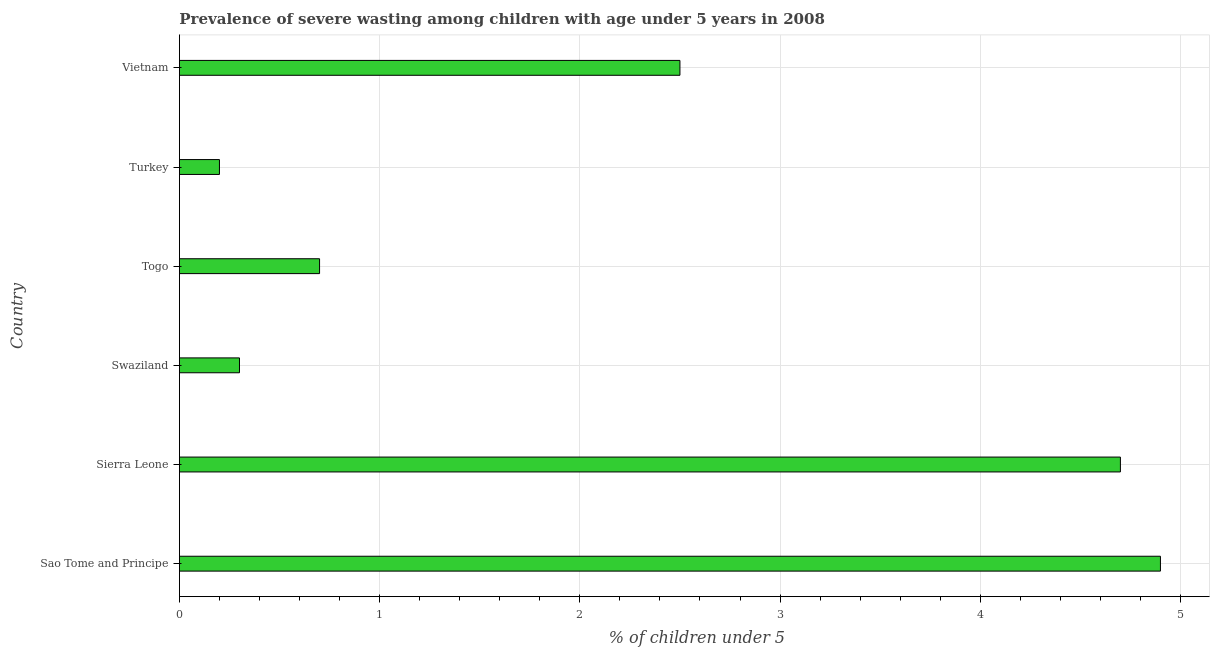Does the graph contain any zero values?
Your response must be concise. No. What is the title of the graph?
Make the answer very short. Prevalence of severe wasting among children with age under 5 years in 2008. What is the label or title of the X-axis?
Offer a very short reply.  % of children under 5. What is the label or title of the Y-axis?
Give a very brief answer. Country. What is the prevalence of severe wasting in Sierra Leone?
Offer a terse response. 4.7. Across all countries, what is the maximum prevalence of severe wasting?
Your response must be concise. 4.9. Across all countries, what is the minimum prevalence of severe wasting?
Your response must be concise. 0.2. In which country was the prevalence of severe wasting maximum?
Provide a succinct answer. Sao Tome and Principe. What is the sum of the prevalence of severe wasting?
Your answer should be compact. 13.3. What is the average prevalence of severe wasting per country?
Offer a very short reply. 2.22. What is the median prevalence of severe wasting?
Your response must be concise. 1.6. What is the ratio of the prevalence of severe wasting in Swaziland to that in Turkey?
Your answer should be very brief. 1.5. Is the sum of the prevalence of severe wasting in Swaziland and Vietnam greater than the maximum prevalence of severe wasting across all countries?
Provide a short and direct response. No. What is the difference between two consecutive major ticks on the X-axis?
Provide a short and direct response. 1. What is the  % of children under 5 in Sao Tome and Principe?
Offer a very short reply. 4.9. What is the  % of children under 5 in Sierra Leone?
Ensure brevity in your answer.  4.7. What is the  % of children under 5 in Swaziland?
Ensure brevity in your answer.  0.3. What is the  % of children under 5 in Togo?
Offer a terse response. 0.7. What is the  % of children under 5 of Turkey?
Your answer should be very brief. 0.2. What is the  % of children under 5 in Vietnam?
Your response must be concise. 2.5. What is the difference between the  % of children under 5 in Sao Tome and Principe and Swaziland?
Keep it short and to the point. 4.6. What is the difference between the  % of children under 5 in Sao Tome and Principe and Turkey?
Make the answer very short. 4.7. What is the difference between the  % of children under 5 in Sierra Leone and Vietnam?
Your answer should be compact. 2.2. What is the difference between the  % of children under 5 in Swaziland and Togo?
Provide a succinct answer. -0.4. What is the difference between the  % of children under 5 in Swaziland and Turkey?
Your answer should be compact. 0.1. What is the difference between the  % of children under 5 in Swaziland and Vietnam?
Ensure brevity in your answer.  -2.2. What is the difference between the  % of children under 5 in Turkey and Vietnam?
Your answer should be very brief. -2.3. What is the ratio of the  % of children under 5 in Sao Tome and Principe to that in Sierra Leone?
Provide a succinct answer. 1.04. What is the ratio of the  % of children under 5 in Sao Tome and Principe to that in Swaziland?
Your response must be concise. 16.33. What is the ratio of the  % of children under 5 in Sao Tome and Principe to that in Vietnam?
Keep it short and to the point. 1.96. What is the ratio of the  % of children under 5 in Sierra Leone to that in Swaziland?
Offer a terse response. 15.67. What is the ratio of the  % of children under 5 in Sierra Leone to that in Togo?
Your response must be concise. 6.71. What is the ratio of the  % of children under 5 in Sierra Leone to that in Vietnam?
Make the answer very short. 1.88. What is the ratio of the  % of children under 5 in Swaziland to that in Togo?
Offer a very short reply. 0.43. What is the ratio of the  % of children under 5 in Swaziland to that in Vietnam?
Offer a terse response. 0.12. What is the ratio of the  % of children under 5 in Togo to that in Vietnam?
Offer a very short reply. 0.28. 